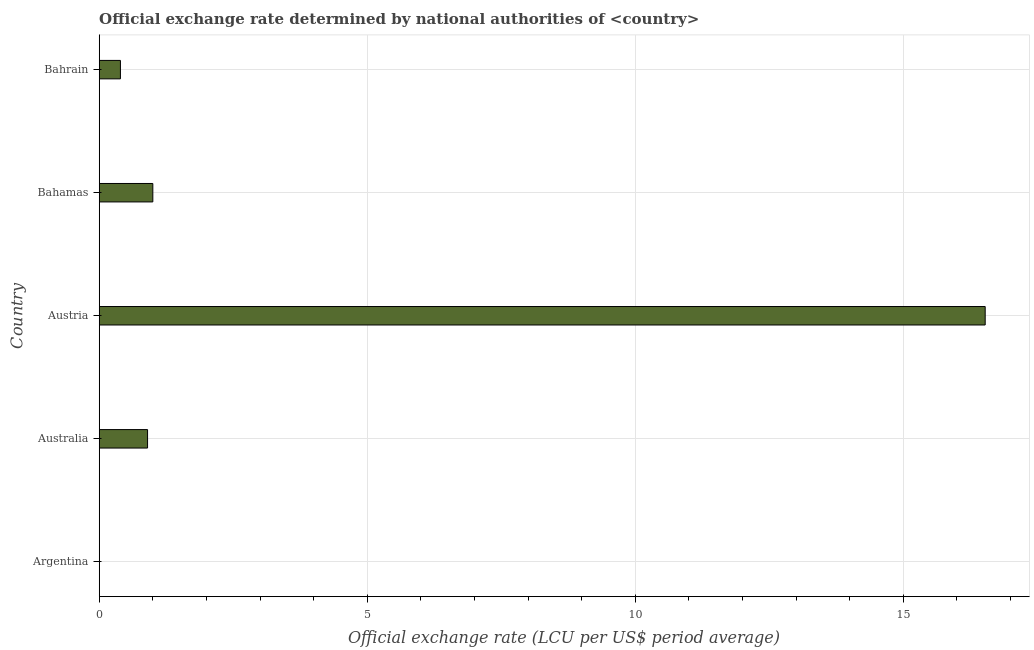What is the title of the graph?
Provide a succinct answer. Official exchange rate determined by national authorities of <country>. What is the label or title of the X-axis?
Your answer should be very brief. Official exchange rate (LCU per US$ period average). What is the official exchange rate in Argentina?
Give a very brief answer. 4.076333333328329e-9. Across all countries, what is the maximum official exchange rate?
Give a very brief answer. 16.53. Across all countries, what is the minimum official exchange rate?
Keep it short and to the point. 4.076333333328329e-9. In which country was the official exchange rate minimum?
Give a very brief answer. Argentina. What is the sum of the official exchange rate?
Your answer should be very brief. 18.82. What is the difference between the official exchange rate in Argentina and Australia?
Your answer should be compact. -0.9. What is the average official exchange rate per country?
Offer a terse response. 3.77. What is the median official exchange rate?
Ensure brevity in your answer.  0.9. In how many countries, is the official exchange rate greater than 4 ?
Your answer should be compact. 1. What is the ratio of the official exchange rate in Australia to that in Bahrain?
Your answer should be very brief. 2.28. Is the official exchange rate in Austria less than that in Bahamas?
Your answer should be compact. No. What is the difference between the highest and the second highest official exchange rate?
Give a very brief answer. 15.53. What is the difference between the highest and the lowest official exchange rate?
Your response must be concise. 16.53. How many bars are there?
Make the answer very short. 5. What is the Official exchange rate (LCU per US$ period average) of Argentina?
Your response must be concise. 4.076333333328329e-9. What is the Official exchange rate (LCU per US$ period average) in Australia?
Offer a terse response. 0.9. What is the Official exchange rate (LCU per US$ period average) in Austria?
Offer a very short reply. 16.53. What is the Official exchange rate (LCU per US$ period average) of Bahamas?
Provide a short and direct response. 1. What is the Official exchange rate (LCU per US$ period average) in Bahrain?
Your response must be concise. 0.4. What is the difference between the Official exchange rate (LCU per US$ period average) in Argentina and Australia?
Provide a succinct answer. -0.9. What is the difference between the Official exchange rate (LCU per US$ period average) in Argentina and Austria?
Keep it short and to the point. -16.53. What is the difference between the Official exchange rate (LCU per US$ period average) in Argentina and Bahamas?
Your answer should be very brief. -1. What is the difference between the Official exchange rate (LCU per US$ period average) in Argentina and Bahrain?
Your answer should be compact. -0.4. What is the difference between the Official exchange rate (LCU per US$ period average) in Australia and Austria?
Your answer should be very brief. -15.63. What is the difference between the Official exchange rate (LCU per US$ period average) in Australia and Bahamas?
Provide a succinct answer. -0.1. What is the difference between the Official exchange rate (LCU per US$ period average) in Australia and Bahrain?
Offer a terse response. 0.51. What is the difference between the Official exchange rate (LCU per US$ period average) in Austria and Bahamas?
Give a very brief answer. 15.53. What is the difference between the Official exchange rate (LCU per US$ period average) in Austria and Bahrain?
Offer a terse response. 16.13. What is the difference between the Official exchange rate (LCU per US$ period average) in Bahamas and Bahrain?
Offer a terse response. 0.6. What is the ratio of the Official exchange rate (LCU per US$ period average) in Argentina to that in Austria?
Your response must be concise. 0. What is the ratio of the Official exchange rate (LCU per US$ period average) in Argentina to that in Bahamas?
Keep it short and to the point. 0. What is the ratio of the Official exchange rate (LCU per US$ period average) in Australia to that in Austria?
Your answer should be compact. 0.06. What is the ratio of the Official exchange rate (LCU per US$ period average) in Australia to that in Bahamas?
Keep it short and to the point. 0.9. What is the ratio of the Official exchange rate (LCU per US$ period average) in Australia to that in Bahrain?
Give a very brief answer. 2.28. What is the ratio of the Official exchange rate (LCU per US$ period average) in Austria to that in Bahamas?
Give a very brief answer. 16.53. What is the ratio of the Official exchange rate (LCU per US$ period average) in Austria to that in Bahrain?
Give a very brief answer. 41.77. What is the ratio of the Official exchange rate (LCU per US$ period average) in Bahamas to that in Bahrain?
Offer a very short reply. 2.53. 